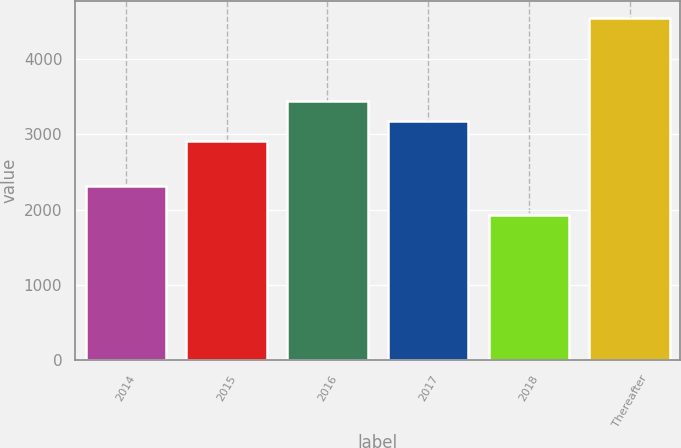Convert chart. <chart><loc_0><loc_0><loc_500><loc_500><bar_chart><fcel>2014<fcel>2015<fcel>2016<fcel>2017<fcel>2018<fcel>Thereafter<nl><fcel>2309<fcel>2914<fcel>3438.2<fcel>3176.1<fcel>1930<fcel>4551<nl></chart> 